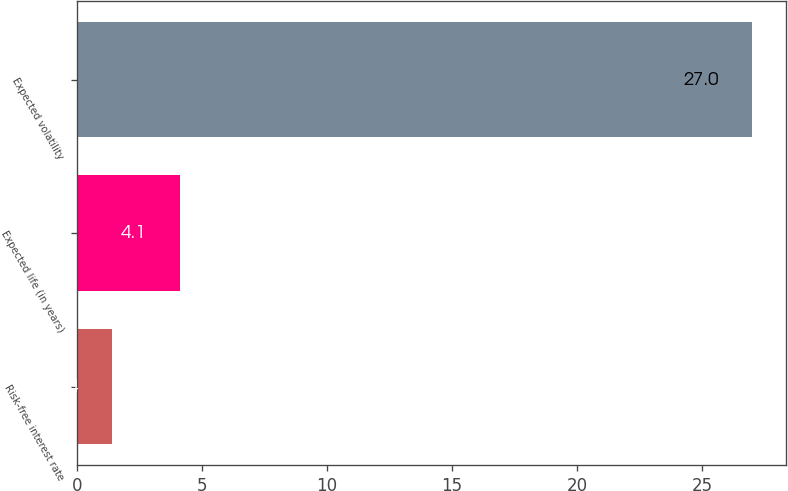Convert chart. <chart><loc_0><loc_0><loc_500><loc_500><bar_chart><fcel>Risk-free interest rate<fcel>Expected life (in years)<fcel>Expected volatility<nl><fcel>1.4<fcel>4.1<fcel>27<nl></chart> 